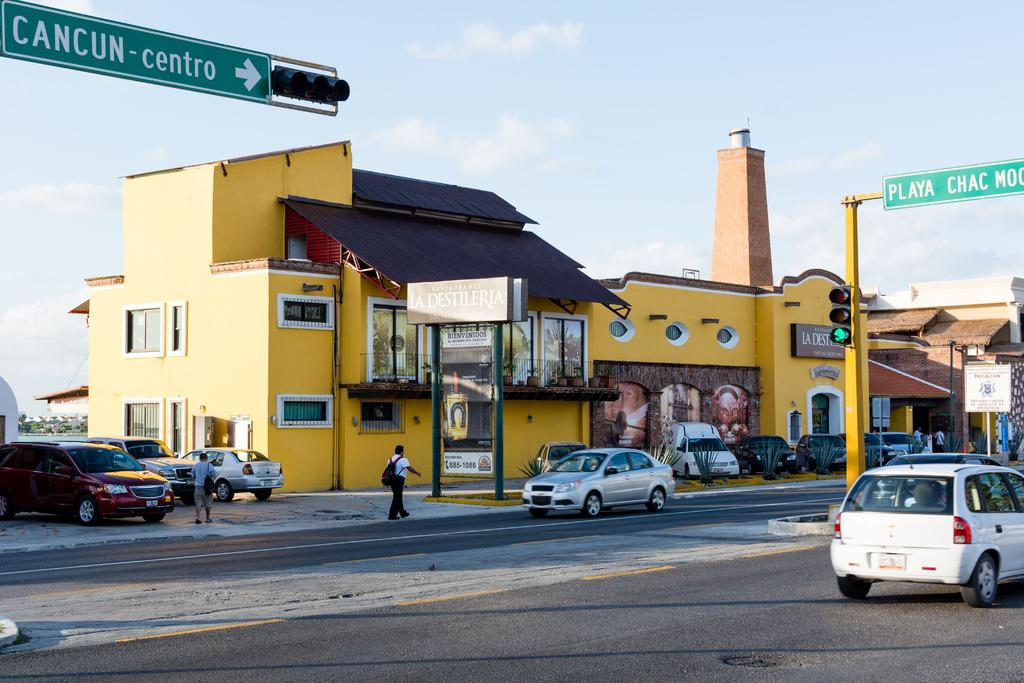What types of objects can be seen in the image? There are vehicles, buildings, trees, signal lights, boards, and hoardings visible in the image. What is the primary feature of the image? The primary feature of the image is a road. What else can be seen in the image? There is a group of people standing in the image. What is visible in the background of the image? The sky is visible in the image. What type of jar can be seen on the table in the image? There is no jar present in the image. What are the people in the image discussing? The image does not show or imply any conversation among the group of people. What type of lunch is being served in the image? There is no mention of lunch or any food in the image. 